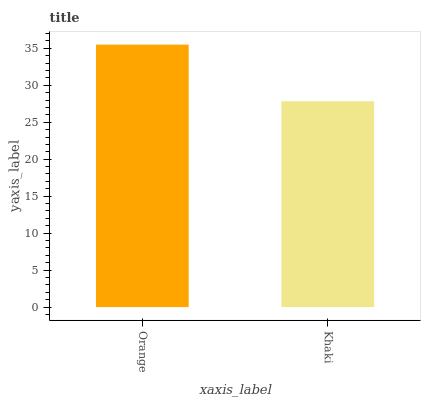Is Khaki the minimum?
Answer yes or no. Yes. Is Orange the maximum?
Answer yes or no. Yes. Is Khaki the maximum?
Answer yes or no. No. Is Orange greater than Khaki?
Answer yes or no. Yes. Is Khaki less than Orange?
Answer yes or no. Yes. Is Khaki greater than Orange?
Answer yes or no. No. Is Orange less than Khaki?
Answer yes or no. No. Is Orange the high median?
Answer yes or no. Yes. Is Khaki the low median?
Answer yes or no. Yes. Is Khaki the high median?
Answer yes or no. No. Is Orange the low median?
Answer yes or no. No. 